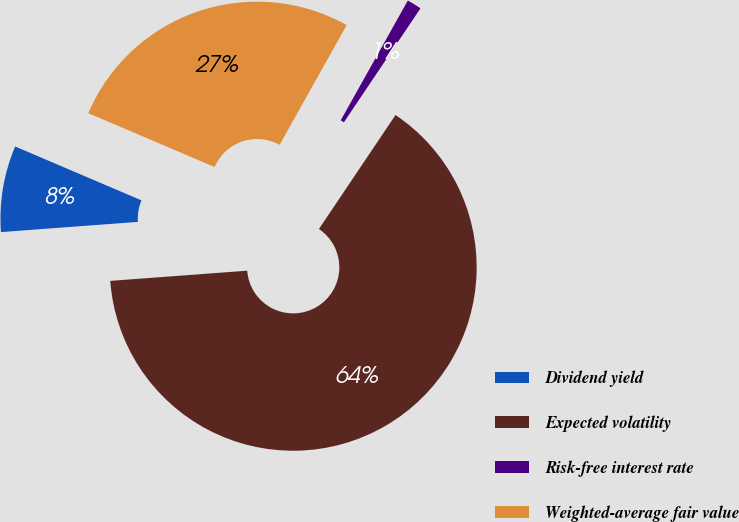Convert chart. <chart><loc_0><loc_0><loc_500><loc_500><pie_chart><fcel>Dividend yield<fcel>Expected volatility<fcel>Risk-free interest rate<fcel>Weighted-average fair value<nl><fcel>7.6%<fcel>64.4%<fcel>1.29%<fcel>26.71%<nl></chart> 